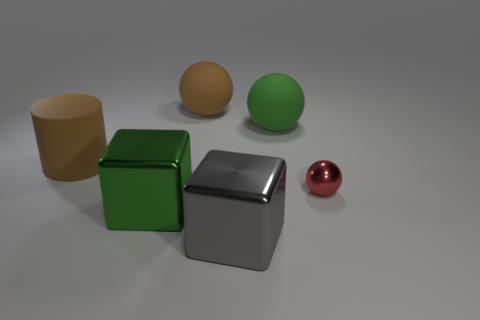Add 2 green metallic blocks. How many objects exist? 8 Subtract all cubes. How many objects are left? 4 Add 2 large cylinders. How many large cylinders exist? 3 Subtract 0 yellow spheres. How many objects are left? 6 Subtract all red metallic balls. Subtract all gray metallic things. How many objects are left? 4 Add 4 big brown rubber cylinders. How many big brown rubber cylinders are left? 5 